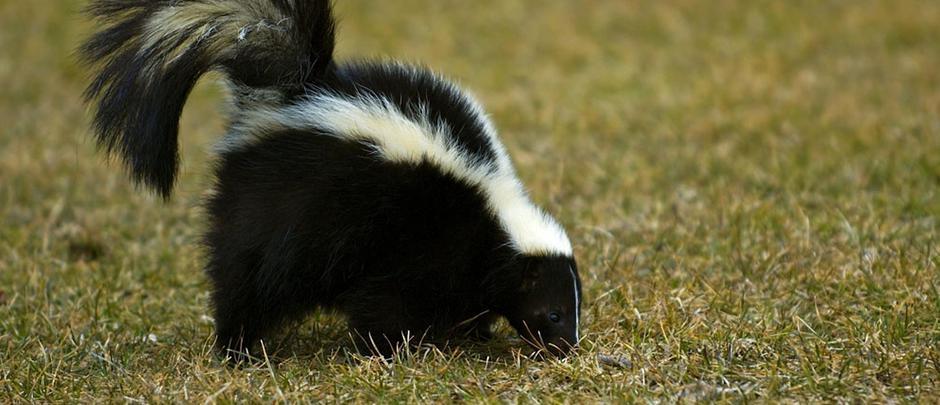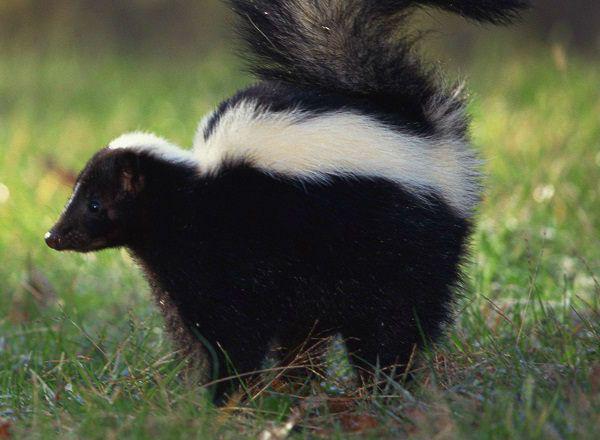The first image is the image on the left, the second image is the image on the right. Given the left and right images, does the statement "A skunk is facing to the right in one image and a skunk is facing to the left in another image." hold true? Answer yes or no. Yes. 